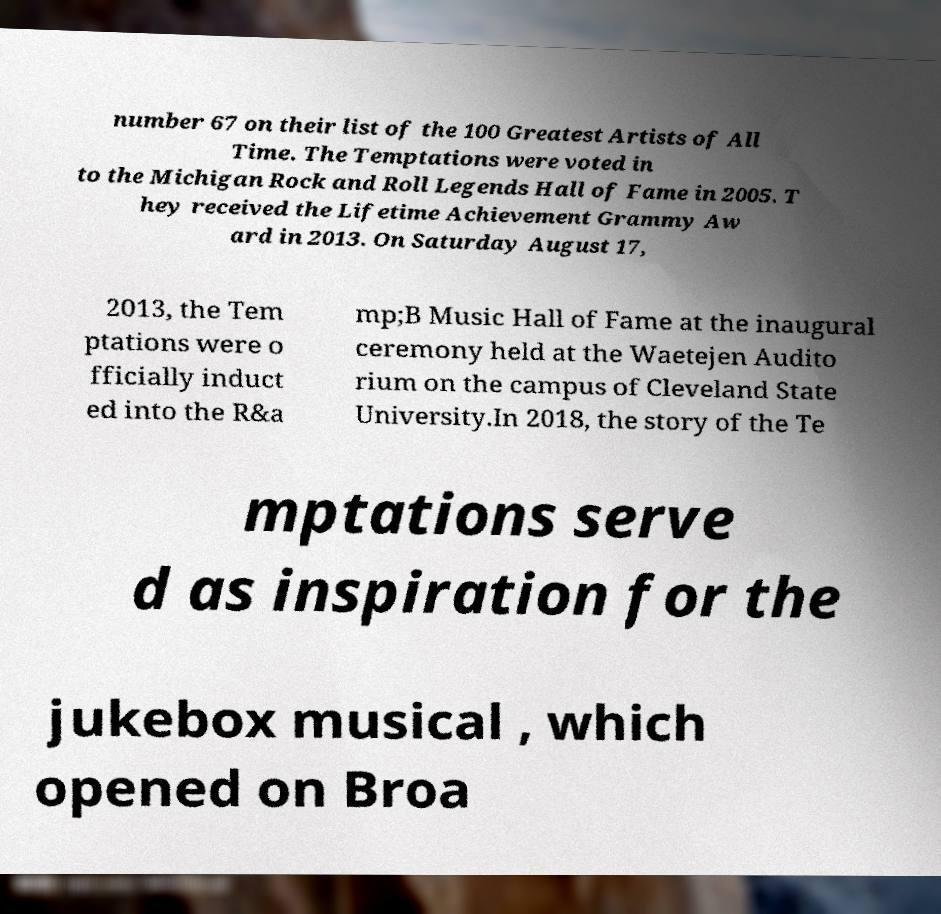Please identify and transcribe the text found in this image. number 67 on their list of the 100 Greatest Artists of All Time. The Temptations were voted in to the Michigan Rock and Roll Legends Hall of Fame in 2005. T hey received the Lifetime Achievement Grammy Aw ard in 2013. On Saturday August 17, 2013, the Tem ptations were o fficially induct ed into the R&a mp;B Music Hall of Fame at the inaugural ceremony held at the Waetejen Audito rium on the campus of Cleveland State University.In 2018, the story of the Te mptations serve d as inspiration for the jukebox musical , which opened on Broa 